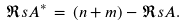<formula> <loc_0><loc_0><loc_500><loc_500>\Re s { A ^ { * } } \, = \, ( n + m ) - \Re s { A } .</formula> 